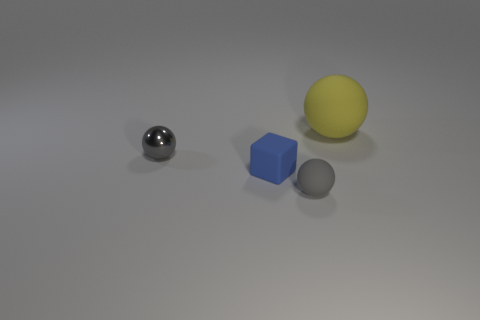There is a rubber thing that is behind the gray object behind the blue rubber cube; what size is it?
Provide a succinct answer. Large. How big is the matte thing that is in front of the big yellow ball and to the right of the blue thing?
Provide a short and direct response. Small. How many blue cylinders have the same size as the gray metallic sphere?
Offer a very short reply. 0. How many metal things are blue things or gray objects?
Offer a very short reply. 1. What size is the thing that is the same color as the small shiny ball?
Keep it short and to the point. Small. There is a small blue thing that is behind the matte ball that is to the left of the yellow matte ball; what is its material?
Offer a very short reply. Rubber. How many things are either balls or small spheres on the right side of the small gray metal object?
Offer a very short reply. 3. There is a block that is made of the same material as the yellow object; what size is it?
Provide a succinct answer. Small. How many yellow objects are either matte spheres or tiny rubber spheres?
Provide a short and direct response. 1. What is the shape of the tiny rubber thing that is the same color as the small shiny ball?
Make the answer very short. Sphere. 